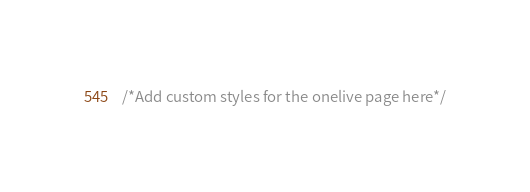Convert code to text. <code><loc_0><loc_0><loc_500><loc_500><_CSS_>/*Add custom styles for the onelive page here*/
</code> 